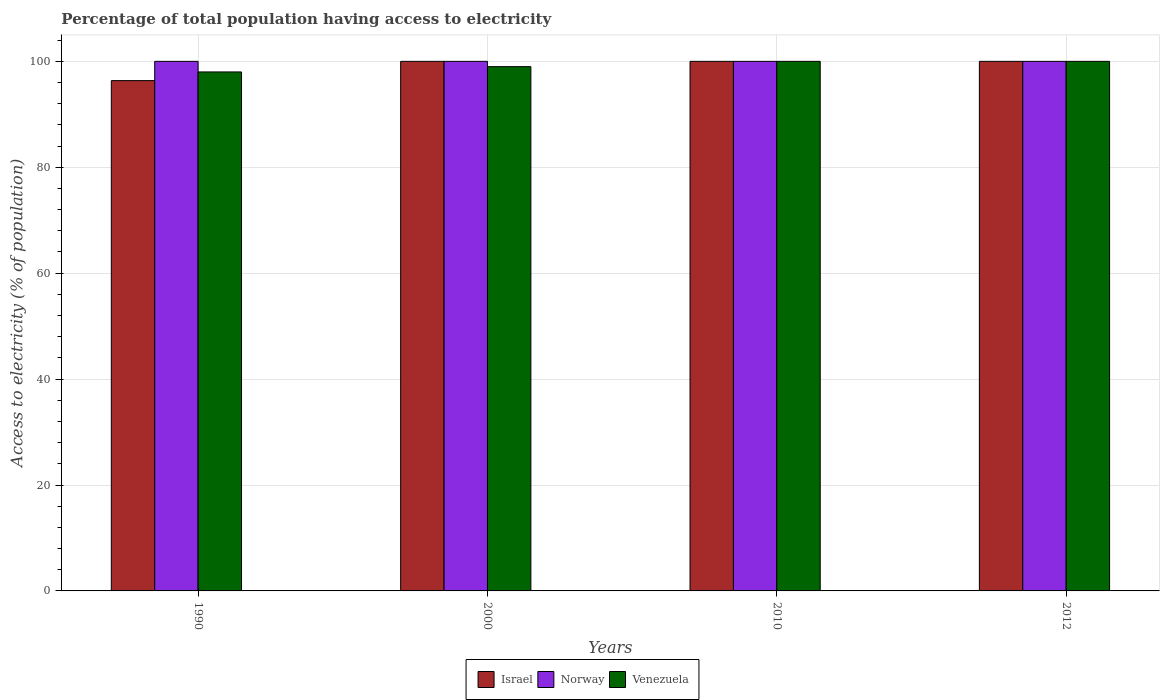Are the number of bars on each tick of the X-axis equal?
Ensure brevity in your answer.  Yes. How many bars are there on the 2nd tick from the left?
Offer a terse response. 3. How many bars are there on the 1st tick from the right?
Keep it short and to the point. 3. What is the label of the 1st group of bars from the left?
Keep it short and to the point. 1990. What is the percentage of population that have access to electricity in Israel in 1990?
Keep it short and to the point. 96.36. Across all years, what is the minimum percentage of population that have access to electricity in Israel?
Your answer should be very brief. 96.36. In which year was the percentage of population that have access to electricity in Israel maximum?
Offer a terse response. 2000. In which year was the percentage of population that have access to electricity in Norway minimum?
Give a very brief answer. 1990. What is the total percentage of population that have access to electricity in Venezuela in the graph?
Give a very brief answer. 397. What is the difference between the percentage of population that have access to electricity in Venezuela in 1990 and that in 2012?
Your answer should be compact. -2. In the year 1990, what is the difference between the percentage of population that have access to electricity in Norway and percentage of population that have access to electricity in Venezuela?
Offer a very short reply. 2. In how many years, is the percentage of population that have access to electricity in Israel greater than 52 %?
Offer a terse response. 4. What is the difference between the highest and the lowest percentage of population that have access to electricity in Norway?
Offer a terse response. 0. Is the sum of the percentage of population that have access to electricity in Venezuela in 2010 and 2012 greater than the maximum percentage of population that have access to electricity in Israel across all years?
Ensure brevity in your answer.  Yes. What does the 3rd bar from the left in 2012 represents?
Keep it short and to the point. Venezuela. What does the 1st bar from the right in 2010 represents?
Your response must be concise. Venezuela. How many years are there in the graph?
Your answer should be compact. 4. Are the values on the major ticks of Y-axis written in scientific E-notation?
Ensure brevity in your answer.  No. Does the graph contain any zero values?
Ensure brevity in your answer.  No. Does the graph contain grids?
Ensure brevity in your answer.  Yes. Where does the legend appear in the graph?
Keep it short and to the point. Bottom center. What is the title of the graph?
Provide a short and direct response. Percentage of total population having access to electricity. Does "Equatorial Guinea" appear as one of the legend labels in the graph?
Your response must be concise. No. What is the label or title of the X-axis?
Ensure brevity in your answer.  Years. What is the label or title of the Y-axis?
Your answer should be compact. Access to electricity (% of population). What is the Access to electricity (% of population) of Israel in 1990?
Provide a short and direct response. 96.36. What is the Access to electricity (% of population) in Venezuela in 1990?
Make the answer very short. 98. What is the Access to electricity (% of population) of Israel in 2000?
Keep it short and to the point. 100. What is the Access to electricity (% of population) in Norway in 2000?
Give a very brief answer. 100. What is the Access to electricity (% of population) in Venezuela in 2000?
Give a very brief answer. 99. What is the Access to electricity (% of population) of Israel in 2010?
Ensure brevity in your answer.  100. What is the Access to electricity (% of population) in Venezuela in 2010?
Your response must be concise. 100. What is the Access to electricity (% of population) of Venezuela in 2012?
Ensure brevity in your answer.  100. Across all years, what is the maximum Access to electricity (% of population) of Venezuela?
Offer a very short reply. 100. Across all years, what is the minimum Access to electricity (% of population) of Israel?
Provide a short and direct response. 96.36. What is the total Access to electricity (% of population) in Israel in the graph?
Ensure brevity in your answer.  396.36. What is the total Access to electricity (% of population) in Norway in the graph?
Your response must be concise. 400. What is the total Access to electricity (% of population) of Venezuela in the graph?
Offer a terse response. 397. What is the difference between the Access to electricity (% of population) of Israel in 1990 and that in 2000?
Keep it short and to the point. -3.64. What is the difference between the Access to electricity (% of population) of Venezuela in 1990 and that in 2000?
Make the answer very short. -1. What is the difference between the Access to electricity (% of population) of Israel in 1990 and that in 2010?
Make the answer very short. -3.64. What is the difference between the Access to electricity (% of population) in Venezuela in 1990 and that in 2010?
Provide a succinct answer. -2. What is the difference between the Access to electricity (% of population) in Israel in 1990 and that in 2012?
Your response must be concise. -3.64. What is the difference between the Access to electricity (% of population) of Norway in 1990 and that in 2012?
Your answer should be very brief. 0. What is the difference between the Access to electricity (% of population) of Israel in 2000 and that in 2010?
Ensure brevity in your answer.  0. What is the difference between the Access to electricity (% of population) of Norway in 2000 and that in 2010?
Your answer should be compact. 0. What is the difference between the Access to electricity (% of population) in Norway in 2000 and that in 2012?
Provide a short and direct response. 0. What is the difference between the Access to electricity (% of population) of Venezuela in 2000 and that in 2012?
Make the answer very short. -1. What is the difference between the Access to electricity (% of population) of Israel in 2010 and that in 2012?
Your answer should be compact. 0. What is the difference between the Access to electricity (% of population) of Venezuela in 2010 and that in 2012?
Give a very brief answer. 0. What is the difference between the Access to electricity (% of population) in Israel in 1990 and the Access to electricity (% of population) in Norway in 2000?
Offer a terse response. -3.64. What is the difference between the Access to electricity (% of population) of Israel in 1990 and the Access to electricity (% of population) of Venezuela in 2000?
Ensure brevity in your answer.  -2.64. What is the difference between the Access to electricity (% of population) in Israel in 1990 and the Access to electricity (% of population) in Norway in 2010?
Your response must be concise. -3.64. What is the difference between the Access to electricity (% of population) in Israel in 1990 and the Access to electricity (% of population) in Venezuela in 2010?
Keep it short and to the point. -3.64. What is the difference between the Access to electricity (% of population) in Norway in 1990 and the Access to electricity (% of population) in Venezuela in 2010?
Your answer should be very brief. 0. What is the difference between the Access to electricity (% of population) in Israel in 1990 and the Access to electricity (% of population) in Norway in 2012?
Ensure brevity in your answer.  -3.64. What is the difference between the Access to electricity (% of population) of Israel in 1990 and the Access to electricity (% of population) of Venezuela in 2012?
Offer a very short reply. -3.64. What is the difference between the Access to electricity (% of population) of Israel in 2000 and the Access to electricity (% of population) of Venezuela in 2010?
Provide a short and direct response. 0. What is the difference between the Access to electricity (% of population) of Israel in 2000 and the Access to electricity (% of population) of Venezuela in 2012?
Offer a terse response. 0. What is the difference between the Access to electricity (% of population) of Norway in 2010 and the Access to electricity (% of population) of Venezuela in 2012?
Offer a terse response. 0. What is the average Access to electricity (% of population) of Israel per year?
Your answer should be very brief. 99.09. What is the average Access to electricity (% of population) in Venezuela per year?
Your response must be concise. 99.25. In the year 1990, what is the difference between the Access to electricity (% of population) of Israel and Access to electricity (% of population) of Norway?
Ensure brevity in your answer.  -3.64. In the year 1990, what is the difference between the Access to electricity (% of population) in Israel and Access to electricity (% of population) in Venezuela?
Your answer should be very brief. -1.64. In the year 1990, what is the difference between the Access to electricity (% of population) in Norway and Access to electricity (% of population) in Venezuela?
Make the answer very short. 2. In the year 2000, what is the difference between the Access to electricity (% of population) in Israel and Access to electricity (% of population) in Norway?
Your response must be concise. 0. In the year 2000, what is the difference between the Access to electricity (% of population) in Israel and Access to electricity (% of population) in Venezuela?
Your response must be concise. 1. In the year 2000, what is the difference between the Access to electricity (% of population) of Norway and Access to electricity (% of population) of Venezuela?
Ensure brevity in your answer.  1. In the year 2010, what is the difference between the Access to electricity (% of population) of Israel and Access to electricity (% of population) of Norway?
Offer a very short reply. 0. In the year 2010, what is the difference between the Access to electricity (% of population) in Israel and Access to electricity (% of population) in Venezuela?
Provide a short and direct response. 0. In the year 2012, what is the difference between the Access to electricity (% of population) in Norway and Access to electricity (% of population) in Venezuela?
Ensure brevity in your answer.  0. What is the ratio of the Access to electricity (% of population) of Israel in 1990 to that in 2000?
Ensure brevity in your answer.  0.96. What is the ratio of the Access to electricity (% of population) of Norway in 1990 to that in 2000?
Give a very brief answer. 1. What is the ratio of the Access to electricity (% of population) of Venezuela in 1990 to that in 2000?
Offer a terse response. 0.99. What is the ratio of the Access to electricity (% of population) of Israel in 1990 to that in 2010?
Provide a succinct answer. 0.96. What is the ratio of the Access to electricity (% of population) of Norway in 1990 to that in 2010?
Make the answer very short. 1. What is the ratio of the Access to electricity (% of population) in Israel in 1990 to that in 2012?
Make the answer very short. 0.96. What is the ratio of the Access to electricity (% of population) in Israel in 2000 to that in 2010?
Provide a short and direct response. 1. What is the ratio of the Access to electricity (% of population) in Venezuela in 2000 to that in 2010?
Ensure brevity in your answer.  0.99. What is the ratio of the Access to electricity (% of population) of Israel in 2000 to that in 2012?
Your answer should be compact. 1. What is the ratio of the Access to electricity (% of population) of Norway in 2000 to that in 2012?
Ensure brevity in your answer.  1. What is the ratio of the Access to electricity (% of population) of Norway in 2010 to that in 2012?
Provide a succinct answer. 1. What is the ratio of the Access to electricity (% of population) in Venezuela in 2010 to that in 2012?
Offer a terse response. 1. What is the difference between the highest and the second highest Access to electricity (% of population) of Venezuela?
Provide a succinct answer. 0. What is the difference between the highest and the lowest Access to electricity (% of population) in Israel?
Your answer should be very brief. 3.64. What is the difference between the highest and the lowest Access to electricity (% of population) in Venezuela?
Ensure brevity in your answer.  2. 